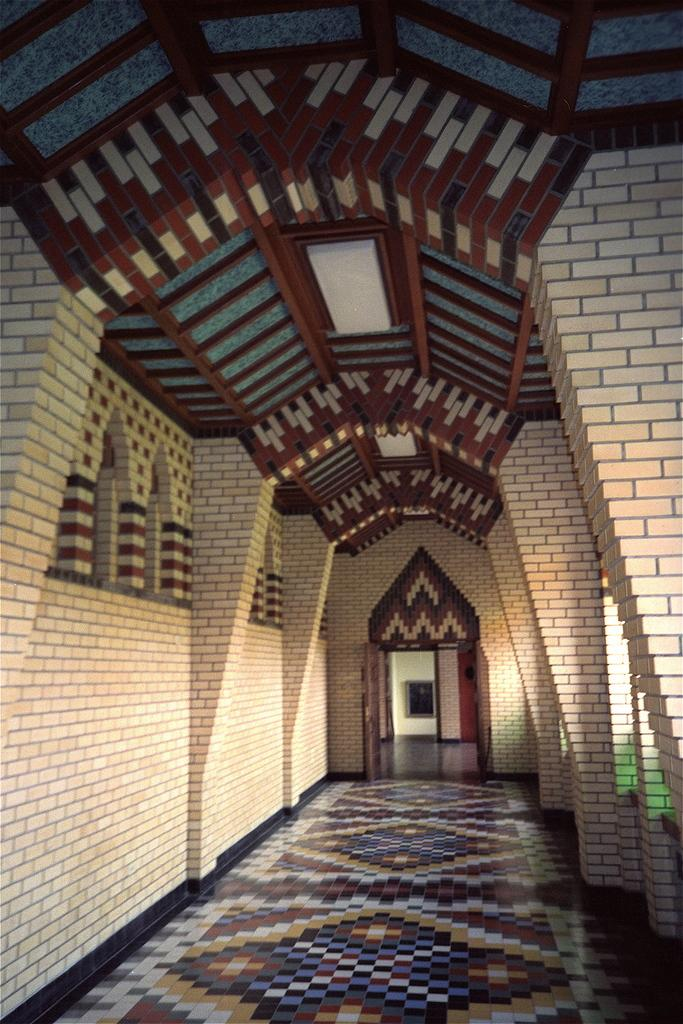What is the main feature of the image? The main feature of the image is a passage. What type of walls are present on the sides of the passage? The walls on the sides of the passage are made of bricks. What can be found at the back of the passage? There are doors at the back of the passage. How many cats are sitting on the picture in the image? There is no picture or cats present in the image. What type of celery is growing in the passage? There is no celery present in the image. 